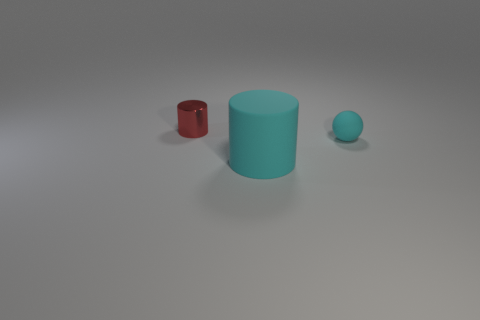Add 2 tiny cyan balls. How many objects exist? 5 Subtract all spheres. How many objects are left? 2 Add 3 rubber spheres. How many rubber spheres exist? 4 Subtract 0 yellow spheres. How many objects are left? 3 Subtract all big matte objects. Subtract all large red cubes. How many objects are left? 2 Add 2 big cylinders. How many big cylinders are left? 3 